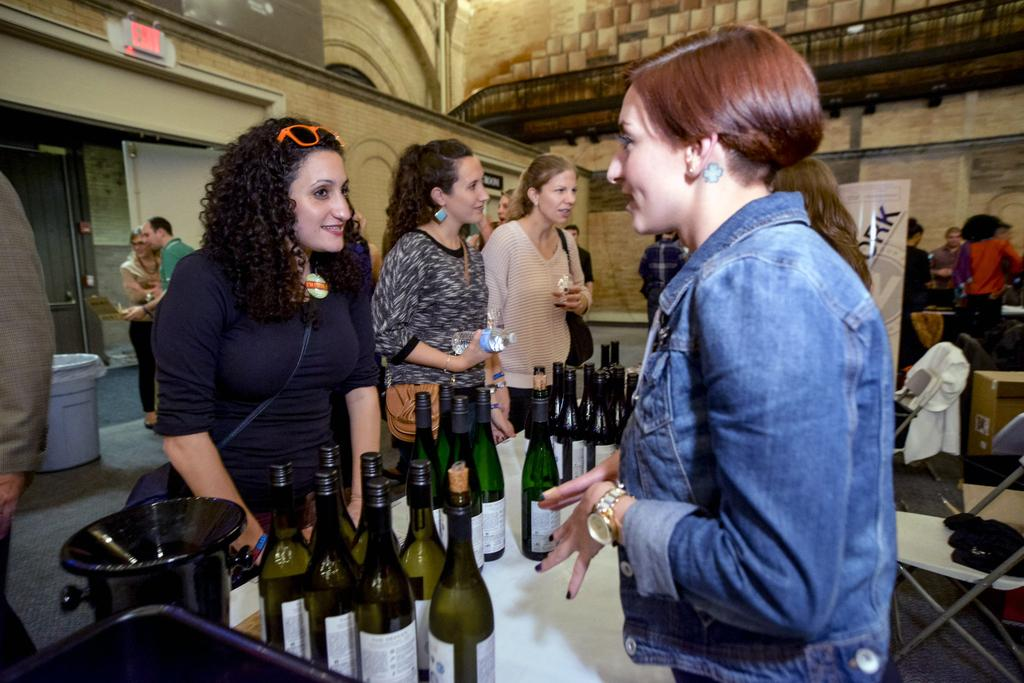What are the people in the image doing? The persons standing on the floor in the image are likely engaged in some activity or event. What is located on the table in the image? There are bottles on the table in the image. What can be seen in the background of the image? There is a wall and a banner in the background of the image. What is the chance of winning a silver medal in the image? There is no indication of a competition or medal in the image, so it is not possible to determine the chance of winning a silver medal. 